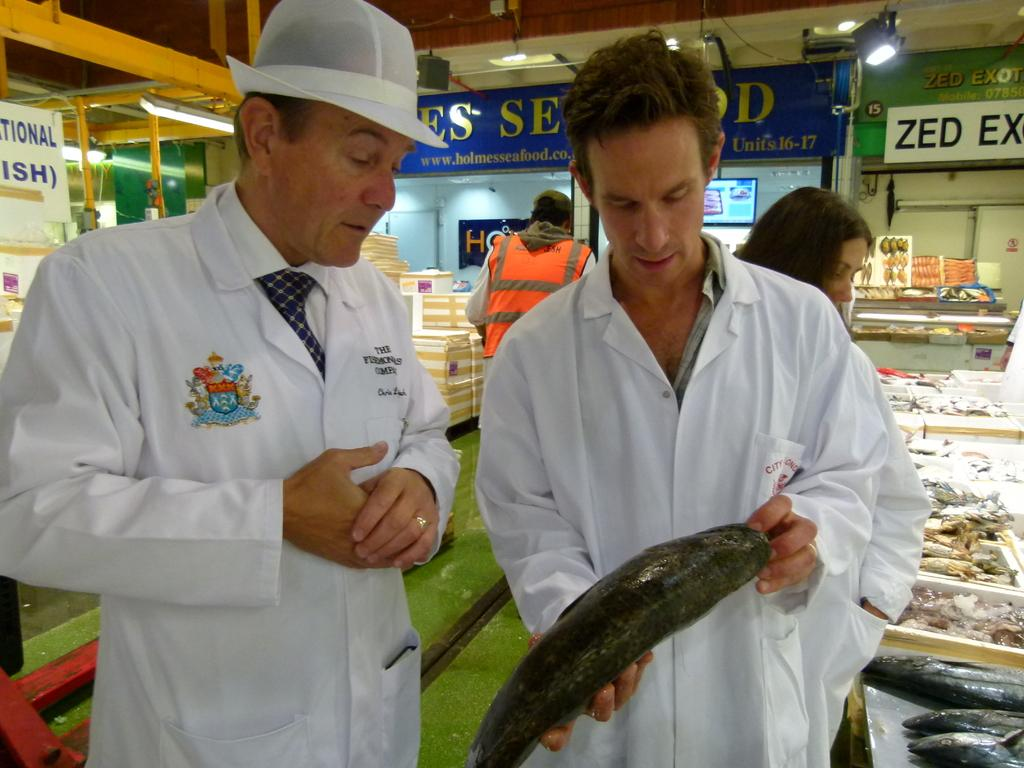<image>
Summarize the visual content of the image. Two men at a market in front of a Zed Ex sign. 